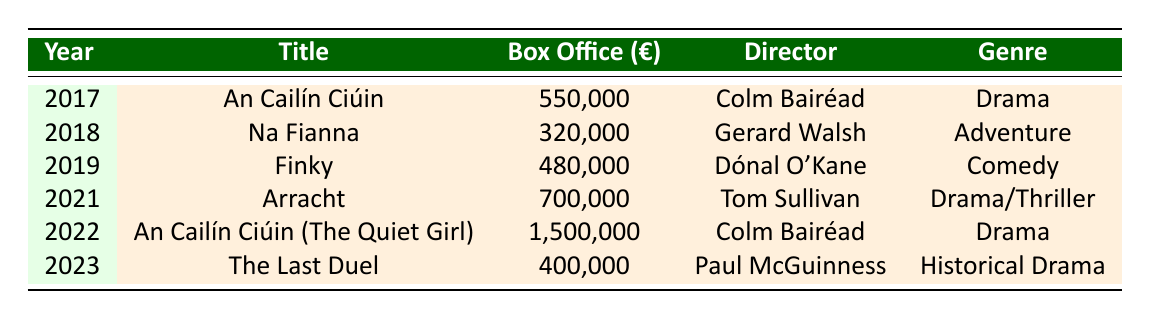What is the title of the film with the highest box office earnings? By examining the box office earnings column, "An Cailín Ciúin (The Quiet Girl)" has the highest earnings of 1,500,000.
Answer: An Cailín Ciúin (The Quiet Girl) Which film was directed by Tom Sullivan? The table lists the director for each film. For the year 2021, "Arracht" is credited to Tom Sullivan.
Answer: Arracht What is the total box office earnings for all the films listed from 2017 to 2023? By summing all the box office earnings: 550000 + 320000 + 480000 + 700000 + 1500000 + 400000 = 3250000.
Answer: 3,250,000 Did any film earn more than 1 million euros at the box office? Checking the box office earnings, "An Cailín Ciúin (The Quiet Girl)" earned 1,500,000, which is more than 1 million.
Answer: Yes What year saw the release of the film "Finky"? Looking at the table, "Finky" was released in 2019.
Answer: 2019 Which genre had the highest box office earnings in 2022? The only film listed for 2022 is "An Cailín Ciúin (The Quiet Girl)," which is a Drama and earned 1,500,000, making it the highest for that year.
Answer: Drama How much more did "Arracht" earn compared to "Na Fianna"? The earnings for "Arracht" are 700000 and "Na Fianna" are 320000. Calculating the difference: 700000 - 320000 = 380000.
Answer: 380,000 Is "An Cailín Ciúin" the title of more than one film listed? The table shows two entries with similar titles: "An Cailín Ciúin" (2017) and "An Cailín Ciúin (The Quiet Girl)" (2022), indicating yes, there are two.
Answer: Yes What is the average box office earnings for the films released in 2018 and 2023? For 2018, "Na Fianna" earned 320000, and for 2023, "The Last Duel" earned 400000. The average is (320000 + 400000) / 2 = 360000.
Answer: 360,000 